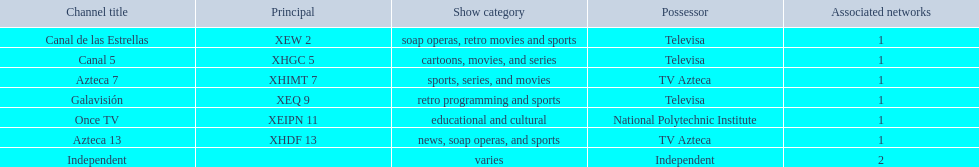What is the average number of affiliates that a given network will have? 1. 